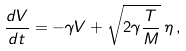<formula> <loc_0><loc_0><loc_500><loc_500>\frac { d V } { d t } = - \gamma V + \sqrt { 2 \gamma \frac { T } { M } } \, \eta \, ,</formula> 